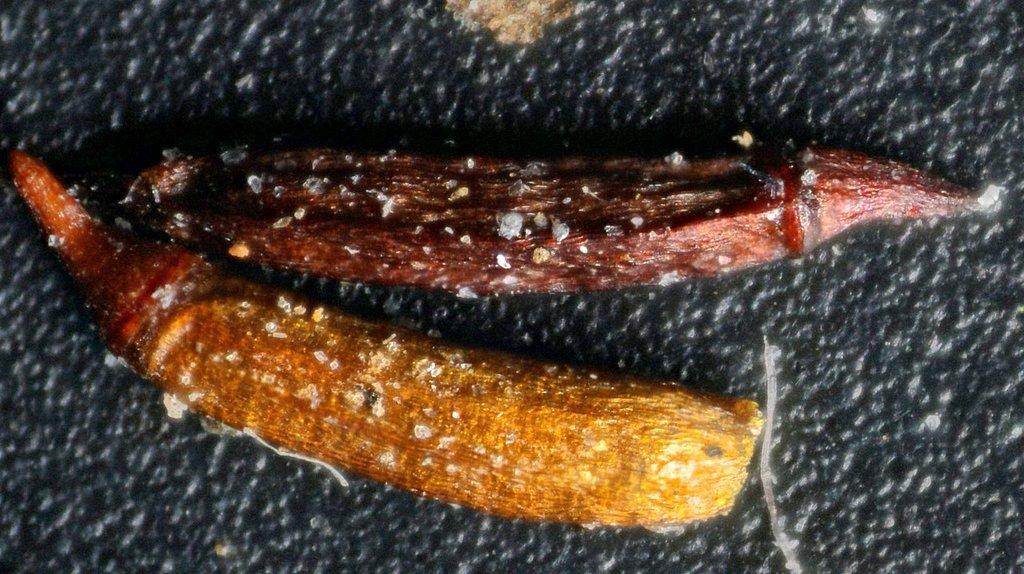What types of items can be seen in the image? There are food items in the image. What is the color of the object on which the food items are placed? The food items are on a black object. What types of toys are visible in the image? There are no toys present in the image; it only features food items on a black object. 